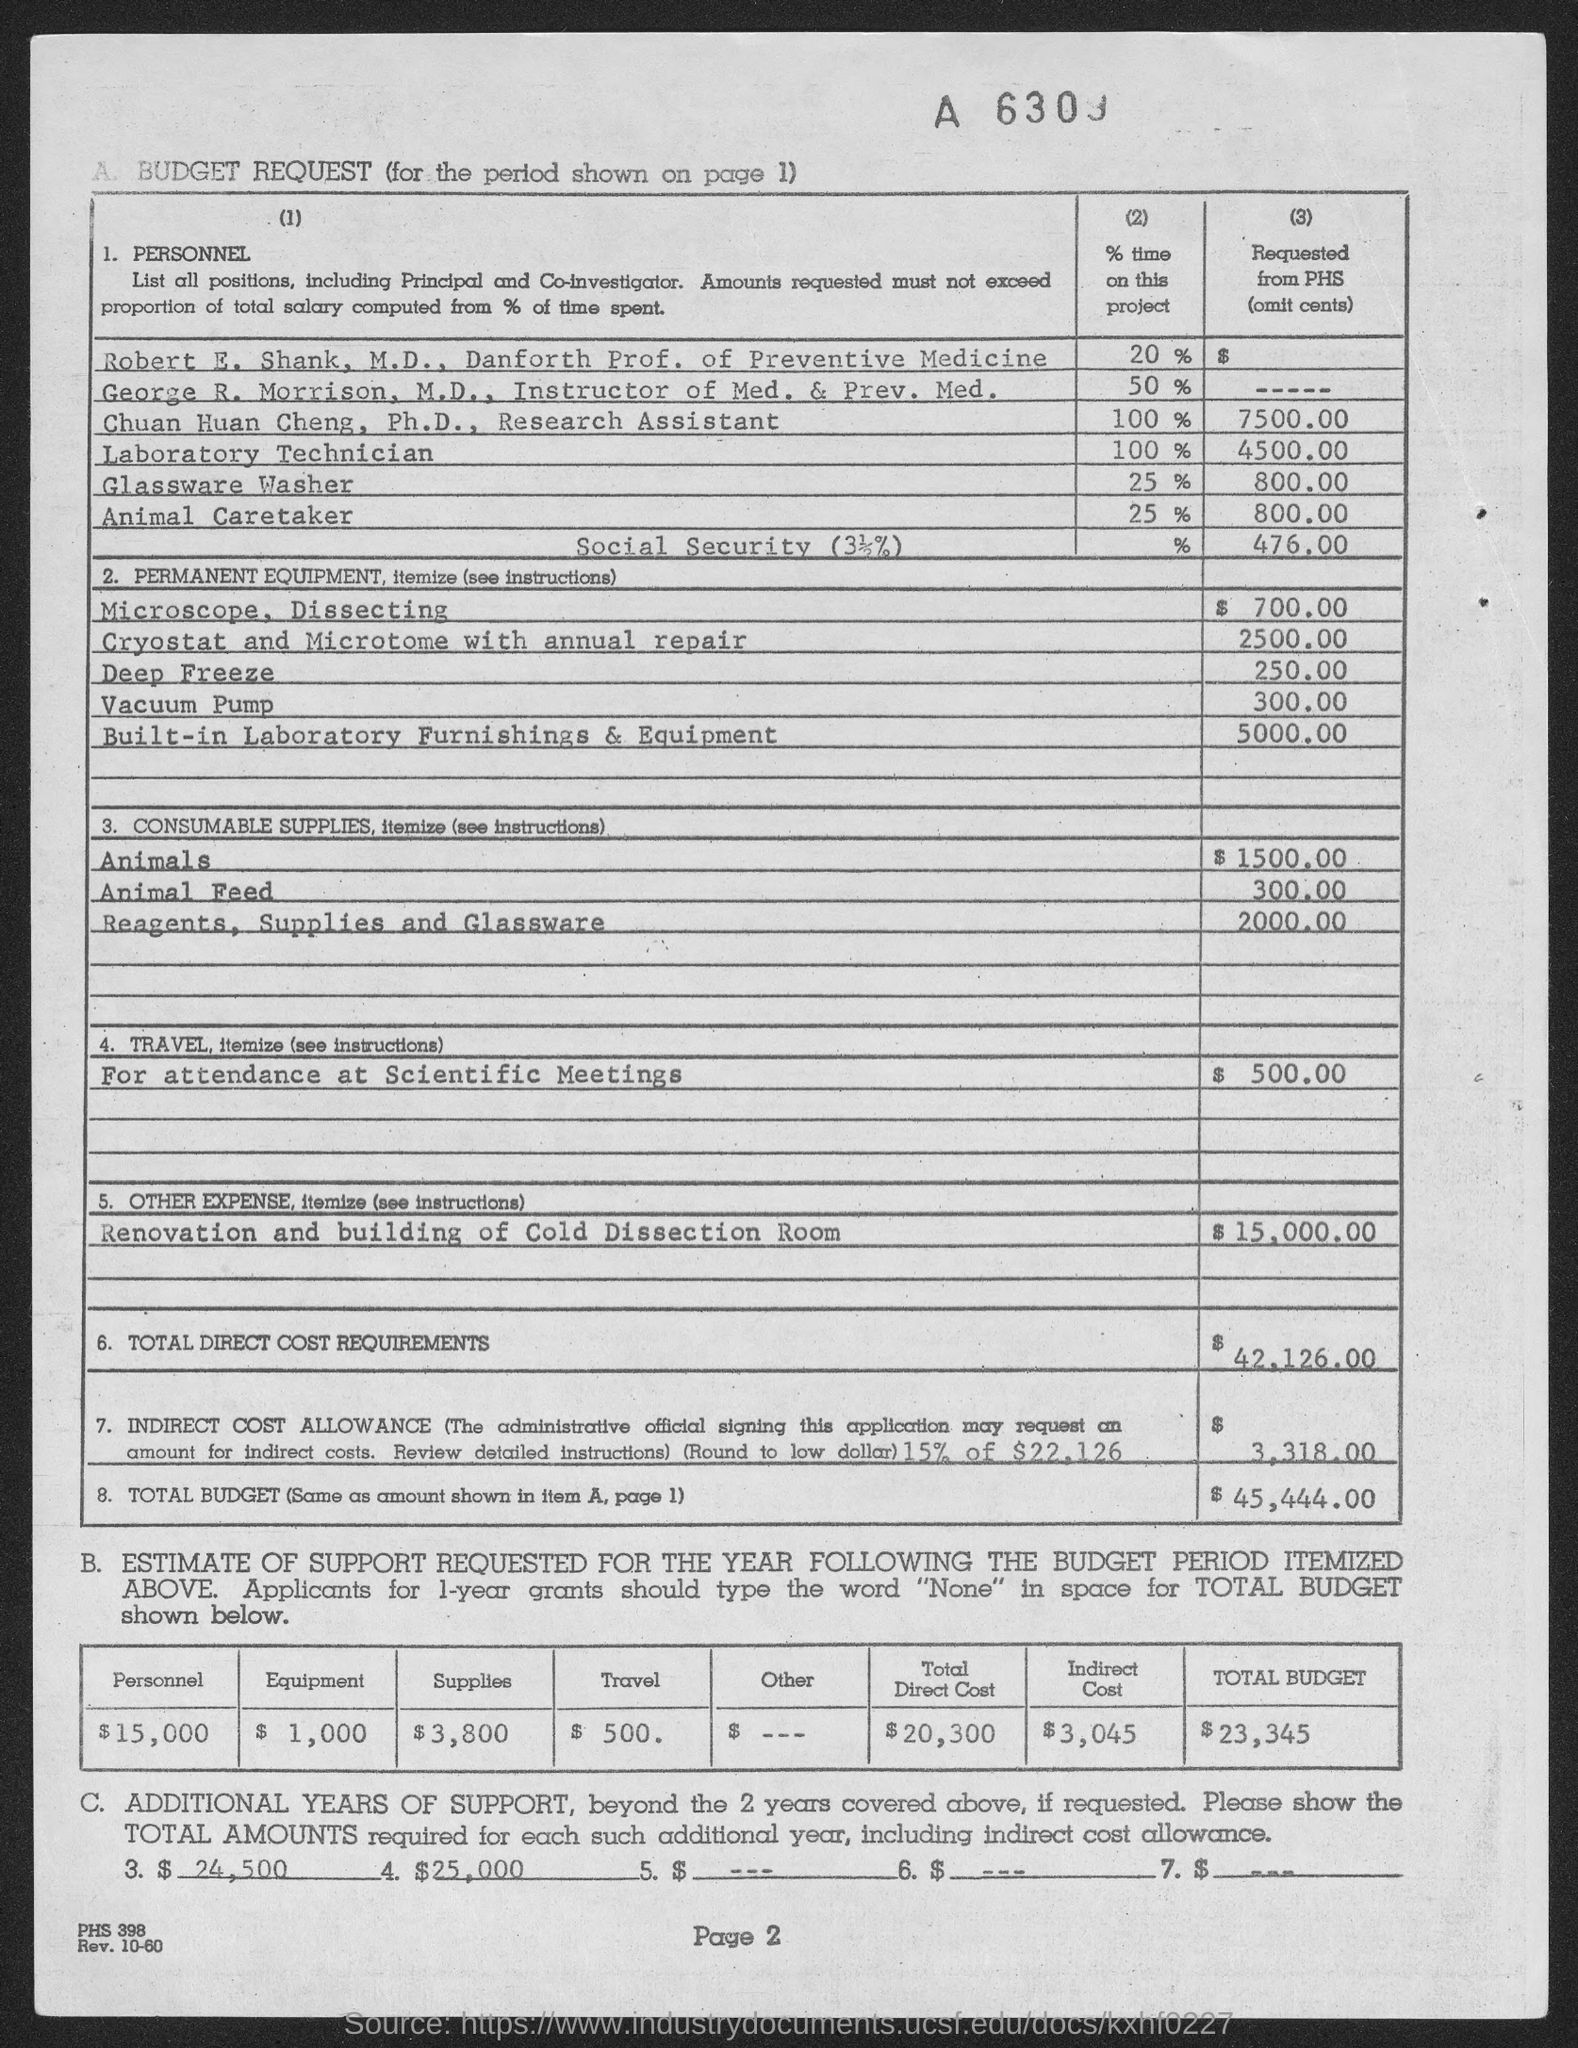What is the page number at bottom of the page?
Keep it short and to the point. Page 2. What is the position of robert e. shank ?
Make the answer very short. Danforth prof. of preventive medicine. What is the position of george r. morrison, m.d.?
Offer a very short reply. Instructor of med. & prev. med. What is the position of chuan huan cheng, ph.d ?
Offer a terse response. Research Assistant. 